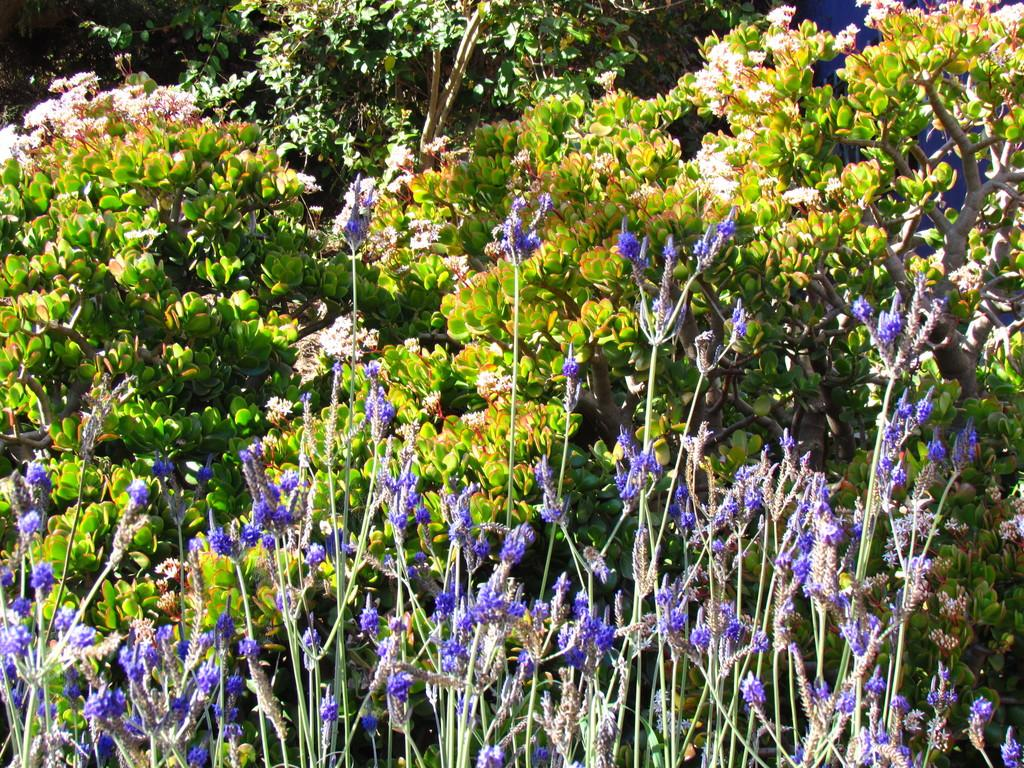What type of vegetation can be seen in the image? There are trees in the image. What other natural elements are present in the image? There are colorful flowers in the image. What type of bike is hanging on the tree in the image? There is no bike present in the image; it only features trees and colorful flowers. What type of apparatus is used to measure the growth of the flowers in the image? There is no apparatus present in the image for measuring the growth of the flowers; the image only shows trees and flowers. 